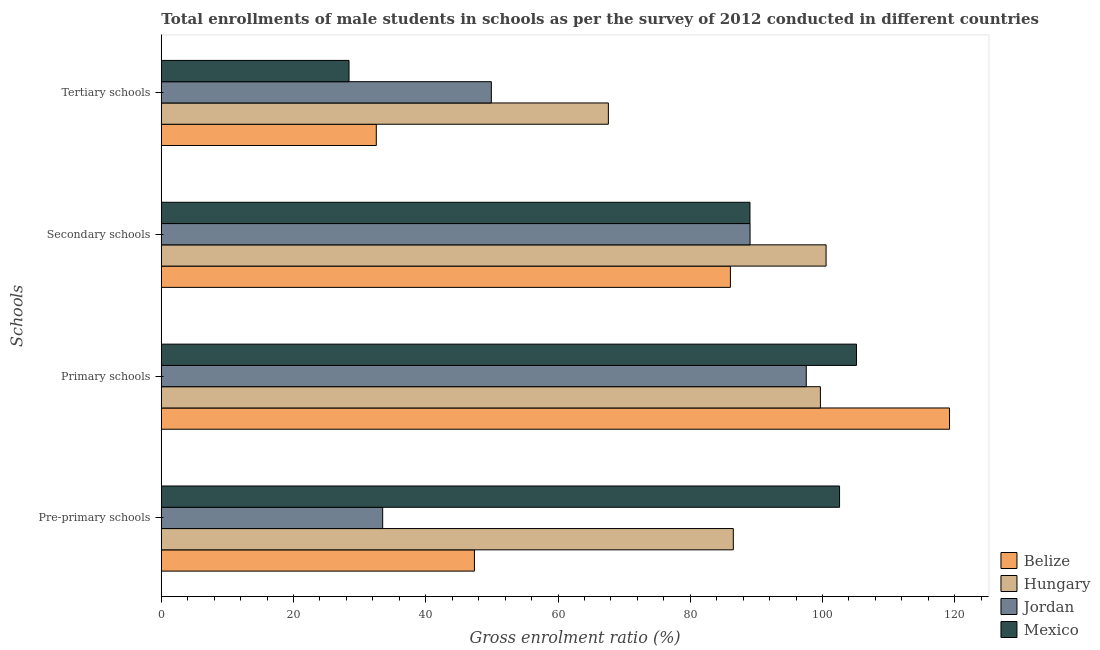How many bars are there on the 1st tick from the top?
Provide a short and direct response. 4. How many bars are there on the 1st tick from the bottom?
Provide a succinct answer. 4. What is the label of the 2nd group of bars from the top?
Give a very brief answer. Secondary schools. What is the gross enrolment ratio(male) in tertiary schools in Mexico?
Provide a succinct answer. 28.39. Across all countries, what is the maximum gross enrolment ratio(male) in tertiary schools?
Make the answer very short. 67.62. Across all countries, what is the minimum gross enrolment ratio(male) in secondary schools?
Provide a short and direct response. 86.07. In which country was the gross enrolment ratio(male) in primary schools maximum?
Your answer should be compact. Belize. In which country was the gross enrolment ratio(male) in secondary schools minimum?
Keep it short and to the point. Belize. What is the total gross enrolment ratio(male) in tertiary schools in the graph?
Offer a terse response. 178.44. What is the difference between the gross enrolment ratio(male) in secondary schools in Mexico and that in Jordan?
Offer a very short reply. -0.01. What is the difference between the gross enrolment ratio(male) in secondary schools in Mexico and the gross enrolment ratio(male) in tertiary schools in Hungary?
Your response must be concise. 21.42. What is the average gross enrolment ratio(male) in pre-primary schools per country?
Keep it short and to the point. 67.48. What is the difference between the gross enrolment ratio(male) in pre-primary schools and gross enrolment ratio(male) in tertiary schools in Belize?
Your answer should be very brief. 14.84. What is the ratio of the gross enrolment ratio(male) in secondary schools in Mexico to that in Hungary?
Provide a short and direct response. 0.89. What is the difference between the highest and the second highest gross enrolment ratio(male) in tertiary schools?
Make the answer very short. 17.7. What is the difference between the highest and the lowest gross enrolment ratio(male) in pre-primary schools?
Make the answer very short. 69.11. What does the 2nd bar from the bottom in Tertiary schools represents?
Offer a very short reply. Hungary. How many bars are there?
Offer a very short reply. 16. What is the difference between two consecutive major ticks on the X-axis?
Offer a very short reply. 20. Does the graph contain any zero values?
Your response must be concise. No. What is the title of the graph?
Your answer should be very brief. Total enrollments of male students in schools as per the survey of 2012 conducted in different countries. Does "Guatemala" appear as one of the legend labels in the graph?
Ensure brevity in your answer.  No. What is the label or title of the X-axis?
Give a very brief answer. Gross enrolment ratio (%). What is the label or title of the Y-axis?
Provide a succinct answer. Schools. What is the Gross enrolment ratio (%) of Belize in Pre-primary schools?
Keep it short and to the point. 47.36. What is the Gross enrolment ratio (%) in Hungary in Pre-primary schools?
Give a very brief answer. 86.52. What is the Gross enrolment ratio (%) of Jordan in Pre-primary schools?
Ensure brevity in your answer.  33.48. What is the Gross enrolment ratio (%) in Mexico in Pre-primary schools?
Offer a terse response. 102.59. What is the Gross enrolment ratio (%) of Belize in Primary schools?
Your answer should be very brief. 119.22. What is the Gross enrolment ratio (%) in Hungary in Primary schools?
Offer a very short reply. 99.69. What is the Gross enrolment ratio (%) in Jordan in Primary schools?
Provide a succinct answer. 97.55. What is the Gross enrolment ratio (%) of Mexico in Primary schools?
Provide a succinct answer. 105.15. What is the Gross enrolment ratio (%) of Belize in Secondary schools?
Ensure brevity in your answer.  86.07. What is the Gross enrolment ratio (%) in Hungary in Secondary schools?
Your response must be concise. 100.55. What is the Gross enrolment ratio (%) of Jordan in Secondary schools?
Your answer should be very brief. 89.05. What is the Gross enrolment ratio (%) in Mexico in Secondary schools?
Offer a very short reply. 89.03. What is the Gross enrolment ratio (%) in Belize in Tertiary schools?
Provide a succinct answer. 32.52. What is the Gross enrolment ratio (%) of Hungary in Tertiary schools?
Your answer should be compact. 67.62. What is the Gross enrolment ratio (%) of Jordan in Tertiary schools?
Offer a very short reply. 49.92. What is the Gross enrolment ratio (%) in Mexico in Tertiary schools?
Make the answer very short. 28.39. Across all Schools, what is the maximum Gross enrolment ratio (%) of Belize?
Make the answer very short. 119.22. Across all Schools, what is the maximum Gross enrolment ratio (%) in Hungary?
Your answer should be compact. 100.55. Across all Schools, what is the maximum Gross enrolment ratio (%) in Jordan?
Ensure brevity in your answer.  97.55. Across all Schools, what is the maximum Gross enrolment ratio (%) of Mexico?
Your answer should be very brief. 105.15. Across all Schools, what is the minimum Gross enrolment ratio (%) of Belize?
Keep it short and to the point. 32.52. Across all Schools, what is the minimum Gross enrolment ratio (%) of Hungary?
Ensure brevity in your answer.  67.62. Across all Schools, what is the minimum Gross enrolment ratio (%) in Jordan?
Provide a succinct answer. 33.48. Across all Schools, what is the minimum Gross enrolment ratio (%) in Mexico?
Your answer should be very brief. 28.39. What is the total Gross enrolment ratio (%) of Belize in the graph?
Your response must be concise. 285.17. What is the total Gross enrolment ratio (%) of Hungary in the graph?
Your answer should be very brief. 354.36. What is the total Gross enrolment ratio (%) in Jordan in the graph?
Your answer should be very brief. 269.99. What is the total Gross enrolment ratio (%) of Mexico in the graph?
Make the answer very short. 325.16. What is the difference between the Gross enrolment ratio (%) of Belize in Pre-primary schools and that in Primary schools?
Offer a terse response. -71.86. What is the difference between the Gross enrolment ratio (%) in Hungary in Pre-primary schools and that in Primary schools?
Ensure brevity in your answer.  -13.17. What is the difference between the Gross enrolment ratio (%) in Jordan in Pre-primary schools and that in Primary schools?
Your response must be concise. -64.07. What is the difference between the Gross enrolment ratio (%) in Mexico in Pre-primary schools and that in Primary schools?
Your answer should be compact. -2.56. What is the difference between the Gross enrolment ratio (%) in Belize in Pre-primary schools and that in Secondary schools?
Offer a very short reply. -38.72. What is the difference between the Gross enrolment ratio (%) of Hungary in Pre-primary schools and that in Secondary schools?
Provide a succinct answer. -14.03. What is the difference between the Gross enrolment ratio (%) in Jordan in Pre-primary schools and that in Secondary schools?
Your answer should be very brief. -55.57. What is the difference between the Gross enrolment ratio (%) in Mexico in Pre-primary schools and that in Secondary schools?
Provide a short and direct response. 13.55. What is the difference between the Gross enrolment ratio (%) in Belize in Pre-primary schools and that in Tertiary schools?
Give a very brief answer. 14.84. What is the difference between the Gross enrolment ratio (%) in Hungary in Pre-primary schools and that in Tertiary schools?
Offer a very short reply. 18.9. What is the difference between the Gross enrolment ratio (%) in Jordan in Pre-primary schools and that in Tertiary schools?
Provide a succinct answer. -16.44. What is the difference between the Gross enrolment ratio (%) in Mexico in Pre-primary schools and that in Tertiary schools?
Give a very brief answer. 74.19. What is the difference between the Gross enrolment ratio (%) of Belize in Primary schools and that in Secondary schools?
Keep it short and to the point. 33.14. What is the difference between the Gross enrolment ratio (%) in Hungary in Primary schools and that in Secondary schools?
Your response must be concise. -0.86. What is the difference between the Gross enrolment ratio (%) in Jordan in Primary schools and that in Secondary schools?
Give a very brief answer. 8.5. What is the difference between the Gross enrolment ratio (%) in Mexico in Primary schools and that in Secondary schools?
Give a very brief answer. 16.11. What is the difference between the Gross enrolment ratio (%) of Belize in Primary schools and that in Tertiary schools?
Offer a terse response. 86.7. What is the difference between the Gross enrolment ratio (%) in Hungary in Primary schools and that in Tertiary schools?
Your answer should be compact. 32.07. What is the difference between the Gross enrolment ratio (%) of Jordan in Primary schools and that in Tertiary schools?
Make the answer very short. 47.63. What is the difference between the Gross enrolment ratio (%) of Mexico in Primary schools and that in Tertiary schools?
Make the answer very short. 76.75. What is the difference between the Gross enrolment ratio (%) in Belize in Secondary schools and that in Tertiary schools?
Make the answer very short. 53.56. What is the difference between the Gross enrolment ratio (%) of Hungary in Secondary schools and that in Tertiary schools?
Your answer should be compact. 32.93. What is the difference between the Gross enrolment ratio (%) of Jordan in Secondary schools and that in Tertiary schools?
Provide a short and direct response. 39.13. What is the difference between the Gross enrolment ratio (%) in Mexico in Secondary schools and that in Tertiary schools?
Your answer should be compact. 60.64. What is the difference between the Gross enrolment ratio (%) in Belize in Pre-primary schools and the Gross enrolment ratio (%) in Hungary in Primary schools?
Provide a succinct answer. -52.33. What is the difference between the Gross enrolment ratio (%) in Belize in Pre-primary schools and the Gross enrolment ratio (%) in Jordan in Primary schools?
Offer a very short reply. -50.19. What is the difference between the Gross enrolment ratio (%) in Belize in Pre-primary schools and the Gross enrolment ratio (%) in Mexico in Primary schools?
Your answer should be compact. -57.79. What is the difference between the Gross enrolment ratio (%) in Hungary in Pre-primary schools and the Gross enrolment ratio (%) in Jordan in Primary schools?
Offer a very short reply. -11.03. What is the difference between the Gross enrolment ratio (%) in Hungary in Pre-primary schools and the Gross enrolment ratio (%) in Mexico in Primary schools?
Keep it short and to the point. -18.63. What is the difference between the Gross enrolment ratio (%) of Jordan in Pre-primary schools and the Gross enrolment ratio (%) of Mexico in Primary schools?
Ensure brevity in your answer.  -71.67. What is the difference between the Gross enrolment ratio (%) of Belize in Pre-primary schools and the Gross enrolment ratio (%) of Hungary in Secondary schools?
Keep it short and to the point. -53.19. What is the difference between the Gross enrolment ratio (%) in Belize in Pre-primary schools and the Gross enrolment ratio (%) in Jordan in Secondary schools?
Your answer should be very brief. -41.69. What is the difference between the Gross enrolment ratio (%) in Belize in Pre-primary schools and the Gross enrolment ratio (%) in Mexico in Secondary schools?
Your response must be concise. -41.68. What is the difference between the Gross enrolment ratio (%) of Hungary in Pre-primary schools and the Gross enrolment ratio (%) of Jordan in Secondary schools?
Give a very brief answer. -2.53. What is the difference between the Gross enrolment ratio (%) in Hungary in Pre-primary schools and the Gross enrolment ratio (%) in Mexico in Secondary schools?
Your answer should be very brief. -2.52. What is the difference between the Gross enrolment ratio (%) of Jordan in Pre-primary schools and the Gross enrolment ratio (%) of Mexico in Secondary schools?
Your answer should be very brief. -55.55. What is the difference between the Gross enrolment ratio (%) of Belize in Pre-primary schools and the Gross enrolment ratio (%) of Hungary in Tertiary schools?
Make the answer very short. -20.26. What is the difference between the Gross enrolment ratio (%) of Belize in Pre-primary schools and the Gross enrolment ratio (%) of Jordan in Tertiary schools?
Ensure brevity in your answer.  -2.56. What is the difference between the Gross enrolment ratio (%) of Belize in Pre-primary schools and the Gross enrolment ratio (%) of Mexico in Tertiary schools?
Keep it short and to the point. 18.97. What is the difference between the Gross enrolment ratio (%) in Hungary in Pre-primary schools and the Gross enrolment ratio (%) in Jordan in Tertiary schools?
Your response must be concise. 36.6. What is the difference between the Gross enrolment ratio (%) of Hungary in Pre-primary schools and the Gross enrolment ratio (%) of Mexico in Tertiary schools?
Give a very brief answer. 58.12. What is the difference between the Gross enrolment ratio (%) in Jordan in Pre-primary schools and the Gross enrolment ratio (%) in Mexico in Tertiary schools?
Provide a short and direct response. 5.09. What is the difference between the Gross enrolment ratio (%) of Belize in Primary schools and the Gross enrolment ratio (%) of Hungary in Secondary schools?
Your answer should be compact. 18.67. What is the difference between the Gross enrolment ratio (%) of Belize in Primary schools and the Gross enrolment ratio (%) of Jordan in Secondary schools?
Provide a short and direct response. 30.17. What is the difference between the Gross enrolment ratio (%) in Belize in Primary schools and the Gross enrolment ratio (%) in Mexico in Secondary schools?
Offer a terse response. 30.18. What is the difference between the Gross enrolment ratio (%) of Hungary in Primary schools and the Gross enrolment ratio (%) of Jordan in Secondary schools?
Make the answer very short. 10.64. What is the difference between the Gross enrolment ratio (%) in Hungary in Primary schools and the Gross enrolment ratio (%) in Mexico in Secondary schools?
Your answer should be very brief. 10.65. What is the difference between the Gross enrolment ratio (%) in Jordan in Primary schools and the Gross enrolment ratio (%) in Mexico in Secondary schools?
Make the answer very short. 8.51. What is the difference between the Gross enrolment ratio (%) of Belize in Primary schools and the Gross enrolment ratio (%) of Hungary in Tertiary schools?
Your response must be concise. 51.6. What is the difference between the Gross enrolment ratio (%) in Belize in Primary schools and the Gross enrolment ratio (%) in Jordan in Tertiary schools?
Keep it short and to the point. 69.3. What is the difference between the Gross enrolment ratio (%) in Belize in Primary schools and the Gross enrolment ratio (%) in Mexico in Tertiary schools?
Make the answer very short. 90.83. What is the difference between the Gross enrolment ratio (%) in Hungary in Primary schools and the Gross enrolment ratio (%) in Jordan in Tertiary schools?
Offer a very short reply. 49.77. What is the difference between the Gross enrolment ratio (%) in Hungary in Primary schools and the Gross enrolment ratio (%) in Mexico in Tertiary schools?
Offer a terse response. 71.3. What is the difference between the Gross enrolment ratio (%) of Jordan in Primary schools and the Gross enrolment ratio (%) of Mexico in Tertiary schools?
Ensure brevity in your answer.  69.16. What is the difference between the Gross enrolment ratio (%) of Belize in Secondary schools and the Gross enrolment ratio (%) of Hungary in Tertiary schools?
Give a very brief answer. 18.46. What is the difference between the Gross enrolment ratio (%) in Belize in Secondary schools and the Gross enrolment ratio (%) in Jordan in Tertiary schools?
Your answer should be compact. 36.16. What is the difference between the Gross enrolment ratio (%) in Belize in Secondary schools and the Gross enrolment ratio (%) in Mexico in Tertiary schools?
Provide a short and direct response. 57.68. What is the difference between the Gross enrolment ratio (%) in Hungary in Secondary schools and the Gross enrolment ratio (%) in Jordan in Tertiary schools?
Ensure brevity in your answer.  50.63. What is the difference between the Gross enrolment ratio (%) in Hungary in Secondary schools and the Gross enrolment ratio (%) in Mexico in Tertiary schools?
Your answer should be very brief. 72.15. What is the difference between the Gross enrolment ratio (%) of Jordan in Secondary schools and the Gross enrolment ratio (%) of Mexico in Tertiary schools?
Ensure brevity in your answer.  60.66. What is the average Gross enrolment ratio (%) of Belize per Schools?
Offer a very short reply. 71.29. What is the average Gross enrolment ratio (%) of Hungary per Schools?
Give a very brief answer. 88.59. What is the average Gross enrolment ratio (%) in Jordan per Schools?
Give a very brief answer. 67.5. What is the average Gross enrolment ratio (%) in Mexico per Schools?
Your response must be concise. 81.29. What is the difference between the Gross enrolment ratio (%) in Belize and Gross enrolment ratio (%) in Hungary in Pre-primary schools?
Give a very brief answer. -39.16. What is the difference between the Gross enrolment ratio (%) in Belize and Gross enrolment ratio (%) in Jordan in Pre-primary schools?
Make the answer very short. 13.88. What is the difference between the Gross enrolment ratio (%) in Belize and Gross enrolment ratio (%) in Mexico in Pre-primary schools?
Ensure brevity in your answer.  -55.23. What is the difference between the Gross enrolment ratio (%) of Hungary and Gross enrolment ratio (%) of Jordan in Pre-primary schools?
Offer a terse response. 53.04. What is the difference between the Gross enrolment ratio (%) in Hungary and Gross enrolment ratio (%) in Mexico in Pre-primary schools?
Offer a very short reply. -16.07. What is the difference between the Gross enrolment ratio (%) of Jordan and Gross enrolment ratio (%) of Mexico in Pre-primary schools?
Give a very brief answer. -69.11. What is the difference between the Gross enrolment ratio (%) of Belize and Gross enrolment ratio (%) of Hungary in Primary schools?
Keep it short and to the point. 19.53. What is the difference between the Gross enrolment ratio (%) in Belize and Gross enrolment ratio (%) in Jordan in Primary schools?
Provide a short and direct response. 21.67. What is the difference between the Gross enrolment ratio (%) in Belize and Gross enrolment ratio (%) in Mexico in Primary schools?
Keep it short and to the point. 14.07. What is the difference between the Gross enrolment ratio (%) of Hungary and Gross enrolment ratio (%) of Jordan in Primary schools?
Ensure brevity in your answer.  2.14. What is the difference between the Gross enrolment ratio (%) of Hungary and Gross enrolment ratio (%) of Mexico in Primary schools?
Offer a terse response. -5.46. What is the difference between the Gross enrolment ratio (%) in Jordan and Gross enrolment ratio (%) in Mexico in Primary schools?
Your answer should be very brief. -7.6. What is the difference between the Gross enrolment ratio (%) in Belize and Gross enrolment ratio (%) in Hungary in Secondary schools?
Keep it short and to the point. -14.47. What is the difference between the Gross enrolment ratio (%) in Belize and Gross enrolment ratio (%) in Jordan in Secondary schools?
Your response must be concise. -2.97. What is the difference between the Gross enrolment ratio (%) of Belize and Gross enrolment ratio (%) of Mexico in Secondary schools?
Your answer should be compact. -2.96. What is the difference between the Gross enrolment ratio (%) in Hungary and Gross enrolment ratio (%) in Jordan in Secondary schools?
Keep it short and to the point. 11.5. What is the difference between the Gross enrolment ratio (%) in Hungary and Gross enrolment ratio (%) in Mexico in Secondary schools?
Provide a succinct answer. 11.51. What is the difference between the Gross enrolment ratio (%) in Jordan and Gross enrolment ratio (%) in Mexico in Secondary schools?
Provide a succinct answer. 0.01. What is the difference between the Gross enrolment ratio (%) of Belize and Gross enrolment ratio (%) of Hungary in Tertiary schools?
Give a very brief answer. -35.1. What is the difference between the Gross enrolment ratio (%) of Belize and Gross enrolment ratio (%) of Jordan in Tertiary schools?
Provide a succinct answer. -17.4. What is the difference between the Gross enrolment ratio (%) of Belize and Gross enrolment ratio (%) of Mexico in Tertiary schools?
Provide a succinct answer. 4.12. What is the difference between the Gross enrolment ratio (%) of Hungary and Gross enrolment ratio (%) of Jordan in Tertiary schools?
Provide a short and direct response. 17.7. What is the difference between the Gross enrolment ratio (%) in Hungary and Gross enrolment ratio (%) in Mexico in Tertiary schools?
Your answer should be compact. 39.22. What is the difference between the Gross enrolment ratio (%) of Jordan and Gross enrolment ratio (%) of Mexico in Tertiary schools?
Provide a succinct answer. 21.52. What is the ratio of the Gross enrolment ratio (%) of Belize in Pre-primary schools to that in Primary schools?
Your answer should be compact. 0.4. What is the ratio of the Gross enrolment ratio (%) in Hungary in Pre-primary schools to that in Primary schools?
Offer a terse response. 0.87. What is the ratio of the Gross enrolment ratio (%) of Jordan in Pre-primary schools to that in Primary schools?
Give a very brief answer. 0.34. What is the ratio of the Gross enrolment ratio (%) in Mexico in Pre-primary schools to that in Primary schools?
Your answer should be compact. 0.98. What is the ratio of the Gross enrolment ratio (%) of Belize in Pre-primary schools to that in Secondary schools?
Make the answer very short. 0.55. What is the ratio of the Gross enrolment ratio (%) in Hungary in Pre-primary schools to that in Secondary schools?
Keep it short and to the point. 0.86. What is the ratio of the Gross enrolment ratio (%) in Jordan in Pre-primary schools to that in Secondary schools?
Ensure brevity in your answer.  0.38. What is the ratio of the Gross enrolment ratio (%) in Mexico in Pre-primary schools to that in Secondary schools?
Give a very brief answer. 1.15. What is the ratio of the Gross enrolment ratio (%) in Belize in Pre-primary schools to that in Tertiary schools?
Offer a very short reply. 1.46. What is the ratio of the Gross enrolment ratio (%) of Hungary in Pre-primary schools to that in Tertiary schools?
Provide a short and direct response. 1.28. What is the ratio of the Gross enrolment ratio (%) in Jordan in Pre-primary schools to that in Tertiary schools?
Give a very brief answer. 0.67. What is the ratio of the Gross enrolment ratio (%) in Mexico in Pre-primary schools to that in Tertiary schools?
Offer a very short reply. 3.61. What is the ratio of the Gross enrolment ratio (%) in Belize in Primary schools to that in Secondary schools?
Offer a terse response. 1.39. What is the ratio of the Gross enrolment ratio (%) of Jordan in Primary schools to that in Secondary schools?
Give a very brief answer. 1.1. What is the ratio of the Gross enrolment ratio (%) of Mexico in Primary schools to that in Secondary schools?
Provide a short and direct response. 1.18. What is the ratio of the Gross enrolment ratio (%) of Belize in Primary schools to that in Tertiary schools?
Your answer should be compact. 3.67. What is the ratio of the Gross enrolment ratio (%) in Hungary in Primary schools to that in Tertiary schools?
Provide a short and direct response. 1.47. What is the ratio of the Gross enrolment ratio (%) in Jordan in Primary schools to that in Tertiary schools?
Provide a succinct answer. 1.95. What is the ratio of the Gross enrolment ratio (%) of Mexico in Primary schools to that in Tertiary schools?
Give a very brief answer. 3.7. What is the ratio of the Gross enrolment ratio (%) in Belize in Secondary schools to that in Tertiary schools?
Your answer should be compact. 2.65. What is the ratio of the Gross enrolment ratio (%) in Hungary in Secondary schools to that in Tertiary schools?
Keep it short and to the point. 1.49. What is the ratio of the Gross enrolment ratio (%) of Jordan in Secondary schools to that in Tertiary schools?
Keep it short and to the point. 1.78. What is the ratio of the Gross enrolment ratio (%) in Mexico in Secondary schools to that in Tertiary schools?
Ensure brevity in your answer.  3.14. What is the difference between the highest and the second highest Gross enrolment ratio (%) of Belize?
Offer a terse response. 33.14. What is the difference between the highest and the second highest Gross enrolment ratio (%) of Hungary?
Ensure brevity in your answer.  0.86. What is the difference between the highest and the second highest Gross enrolment ratio (%) of Jordan?
Your answer should be very brief. 8.5. What is the difference between the highest and the second highest Gross enrolment ratio (%) of Mexico?
Ensure brevity in your answer.  2.56. What is the difference between the highest and the lowest Gross enrolment ratio (%) of Belize?
Keep it short and to the point. 86.7. What is the difference between the highest and the lowest Gross enrolment ratio (%) of Hungary?
Your response must be concise. 32.93. What is the difference between the highest and the lowest Gross enrolment ratio (%) in Jordan?
Keep it short and to the point. 64.07. What is the difference between the highest and the lowest Gross enrolment ratio (%) of Mexico?
Offer a terse response. 76.75. 